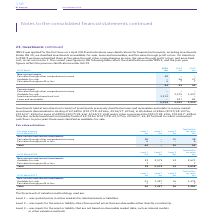From Bt Group Plc's financial document, What were the  Fair value through profit or loss  in 2019, 2018 and 2017 respectively? The document contains multiple relevant values: 54, 53, 44 (in millions). From the document: "54 53 44 54 53 44 54 53 44..." Also, What were the investments in liquidity funds in 2019, 2018 and 2017 respectively? The document contains multiple relevant values: £2,522m, £2,575m, £1,437m. From the document: "hey also include investments in liquidity funds of £2,522m (2017/18: £2,575m, 2016/17: £1,437m) held to collect contractual cash flows. In prior years..." Also, When was the IFRS 9 applied? According to the financial document, 1 April 2018. The relevant text states: "IFRS 9 was applied for the first time on 1 April 2018 and introduces new classifications for financial instruments, including investments. Under IAS 39,..." Also, can you calculate: What is the change in the Fair value through other comprehensive income from 2017 to 2018? Based on the calculation: 46 - 37, the result is 9 (in millions). This is based on the information: "mprehensive income 48 – – Available-for-sale – 46 37 Fair value through profit or loss 6 7 7 comprehensive income 48 – – Available-for-sale – 46 37 Fair value through profit or loss 6 7 7..." The key data points involved are: 37, 46. Additionally, Which year(s) has Fair value through profit or loss greater than 50 million? The document shows two values: 2019 and 2018. From the document: "At 31 March 2019 £m 2018 £m 2017 £m At 31 March 2019 £m 2018 £m 2017 £m..." Also, can you calculate: What is the average Loans and receivables for 2017-2019? To answer this question, I need to perform calculations using the financial data. The calculation is: (0 + 447 + 83) / 3, which equals 176.67 (in millions). This is based on the information: "rtised cost 3,214 – – Loans and receivables – 447 83 At 31 March 2019 £m 2018 £m 2017 £m amortised cost 3,214 – – Loans and receivables – 447 83..." The key data points involved are: 0, 447, 83. 